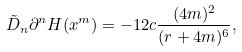Convert formula to latex. <formula><loc_0><loc_0><loc_500><loc_500>\tilde { D } _ { n } \partial ^ { n } H ( x ^ { m } ) = - 1 2 c \frac { ( 4 m ) ^ { 2 } } { ( r + 4 m ) ^ { 6 } } ,</formula> 